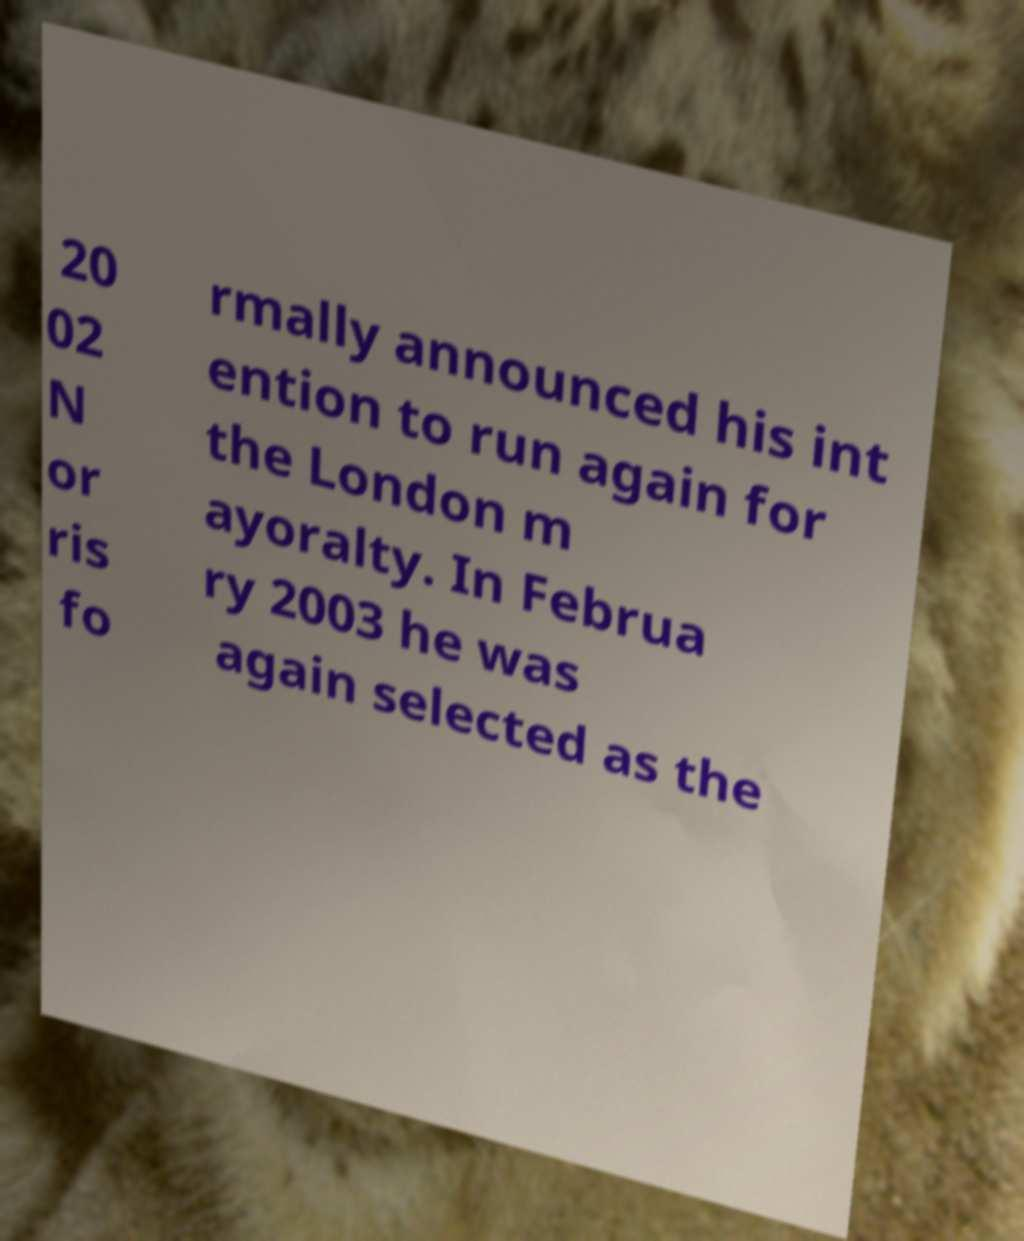Could you assist in decoding the text presented in this image and type it out clearly? 20 02 N or ris fo rmally announced his int ention to run again for the London m ayoralty. In Februa ry 2003 he was again selected as the 